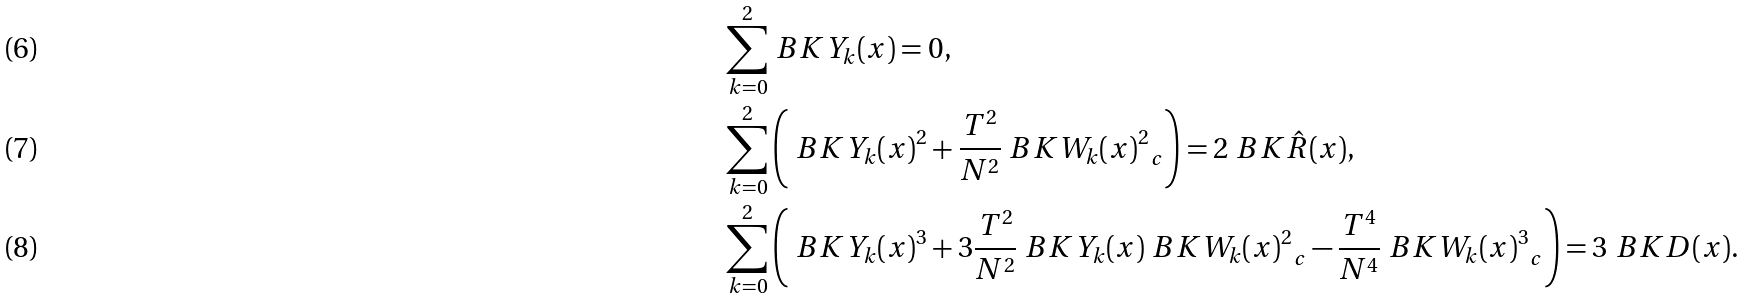<formula> <loc_0><loc_0><loc_500><loc_500>\sum _ { k = 0 } ^ { 2 } & \ B K { Y _ { k } ( x ) } = 0 , \\ \sum _ { k = 0 } ^ { 2 } & \left ( \ B K { Y _ { k } ( x ) } ^ { 2 } + \frac { T ^ { 2 } } { N ^ { 2 } } \ B K { W _ { k } ( x ) ^ { 2 } } _ { c } \right ) = 2 \ B K { \hat { R } ( x ) } , \\ \sum _ { k = 0 } ^ { 2 } & \left ( \ B K { Y _ { k } ( x ) } ^ { 3 } + 3 \frac { T ^ { 2 } } { N ^ { 2 } } \ B K { Y _ { k } ( x ) } \ B K { W _ { k } ( x ) ^ { 2 } } _ { c } - \frac { T ^ { 4 } } { N ^ { 4 } } \ B K { W _ { k } ( x ) ^ { 3 } } _ { c } \right ) = 3 \ B K { D ( x ) } .</formula> 